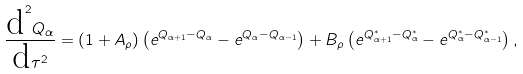<formula> <loc_0><loc_0><loc_500><loc_500>\frac { \text {d} ^ { 2 } Q _ { \alpha } } { \text {d} \tau ^ { 2 } } = ( 1 + A _ { \rho } ) \left ( e ^ { Q _ { \alpha + 1 } - Q _ { \alpha } } - e ^ { Q _ { \alpha } - Q _ { \alpha - 1 } } \right ) + B _ { \rho } \left ( e ^ { Q ^ { * } _ { \alpha + 1 } - Q ^ { * } _ { \alpha } } - e ^ { Q ^ { * } _ { \alpha } - Q ^ { * } _ { \alpha - 1 } } \right ) ,</formula> 